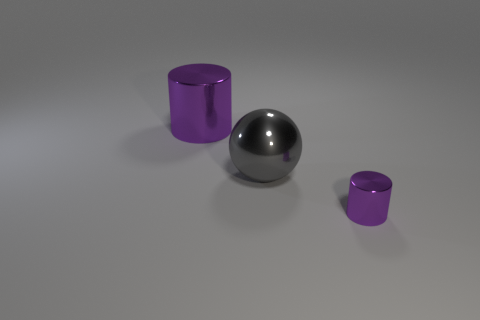Are there any spheres behind the large metallic object that is behind the ball?
Offer a very short reply. No. How many big purple objects are there?
Your response must be concise. 1. There is a tiny cylinder; is it the same color as the cylinder that is behind the tiny cylinder?
Provide a succinct answer. Yes. Is the number of big purple cylinders greater than the number of big metallic things?
Ensure brevity in your answer.  No. Are there any other things that have the same color as the large sphere?
Ensure brevity in your answer.  No. There is a purple object behind the purple shiny object on the right side of the object behind the gray metallic sphere; what is it made of?
Your response must be concise. Metal. Are the large gray ball and the cylinder that is on the left side of the small metal thing made of the same material?
Provide a succinct answer. Yes. Are there fewer tiny purple things that are on the right side of the big sphere than shiny things to the right of the large shiny cylinder?
Provide a short and direct response. Yes. What number of big red blocks are made of the same material as the large purple cylinder?
Give a very brief answer. 0. Are there any cylinders right of the purple metallic thing left of the metallic cylinder on the right side of the big gray metal sphere?
Your response must be concise. Yes. 